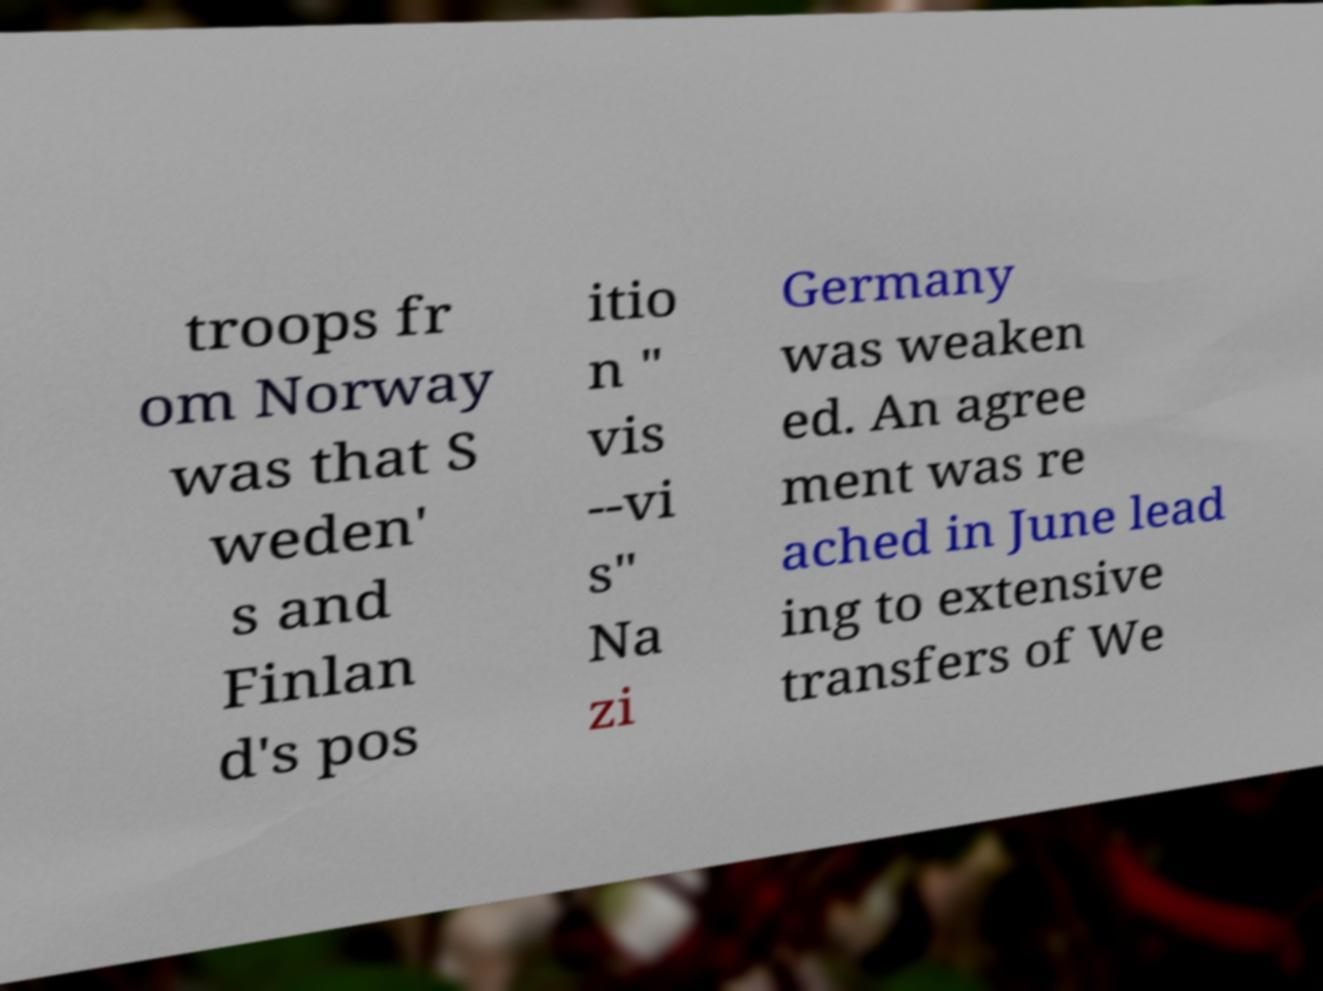Please read and relay the text visible in this image. What does it say? troops fr om Norway was that S weden' s and Finlan d's pos itio n " vis --vi s" Na zi Germany was weaken ed. An agree ment was re ached in June lead ing to extensive transfers of We 